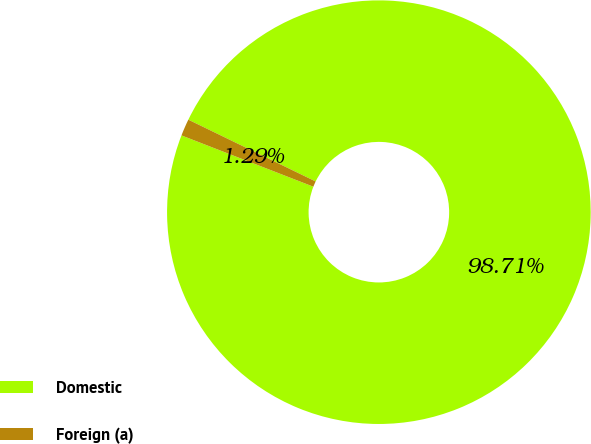Convert chart. <chart><loc_0><loc_0><loc_500><loc_500><pie_chart><fcel>Domestic<fcel>Foreign (a)<nl><fcel>98.71%<fcel>1.29%<nl></chart> 